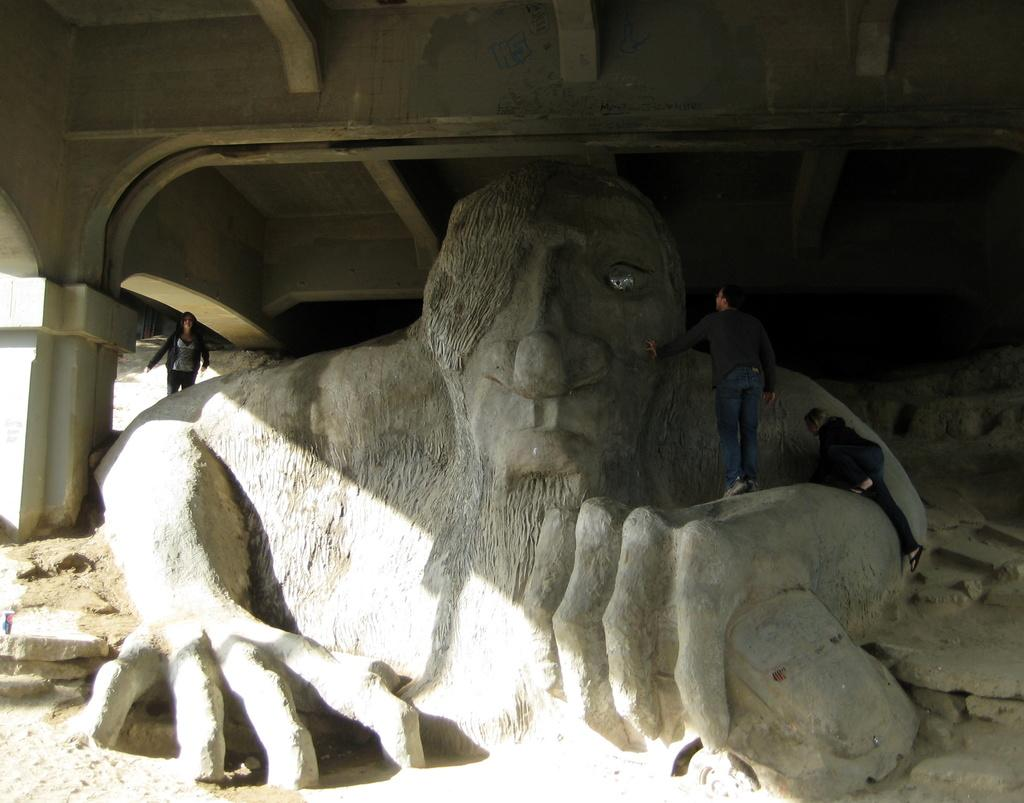What is the main subject of the image? There is a sculpture in the image. What are the people in the image doing? Three persons are standing on the sculpture. What can be seen at the top of the image? There is a roof with pillars at the top of the image. What type of surface is visible on the ground in the image? There are stones on the ground in the image. What type of locket is the aunt holding in the image? There is no aunt or locket present in the image. What is the aunt's head doing in the image? There is no aunt or head present in the image. 